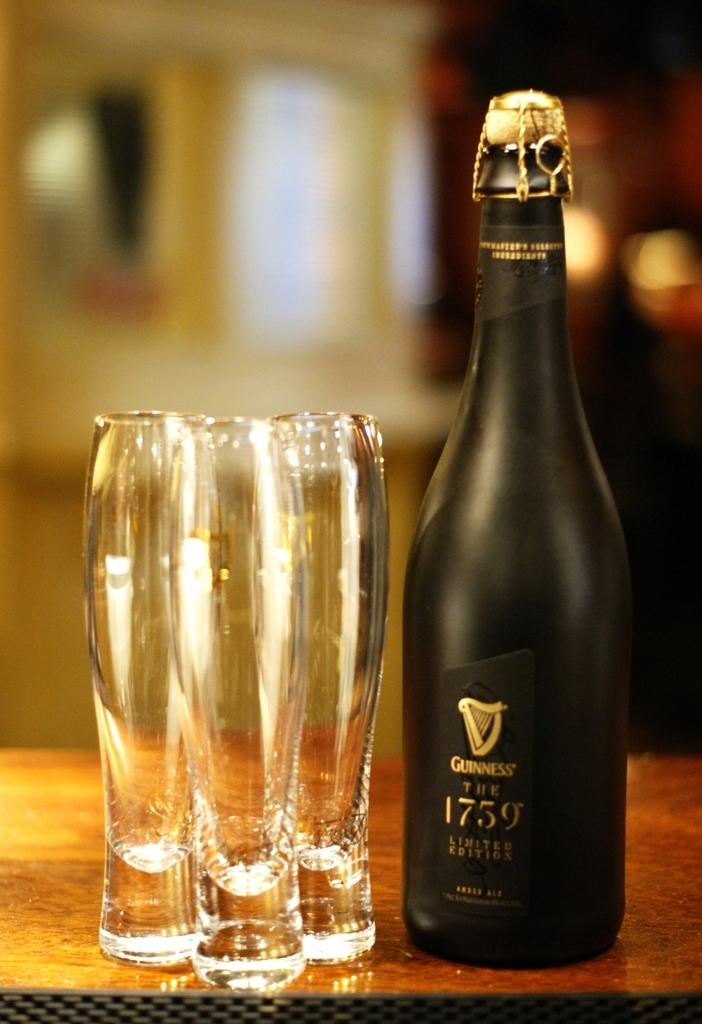<image>
Offer a succinct explanation of the picture presented. A black bottle with 1759 printed on the front next to three glasses. 